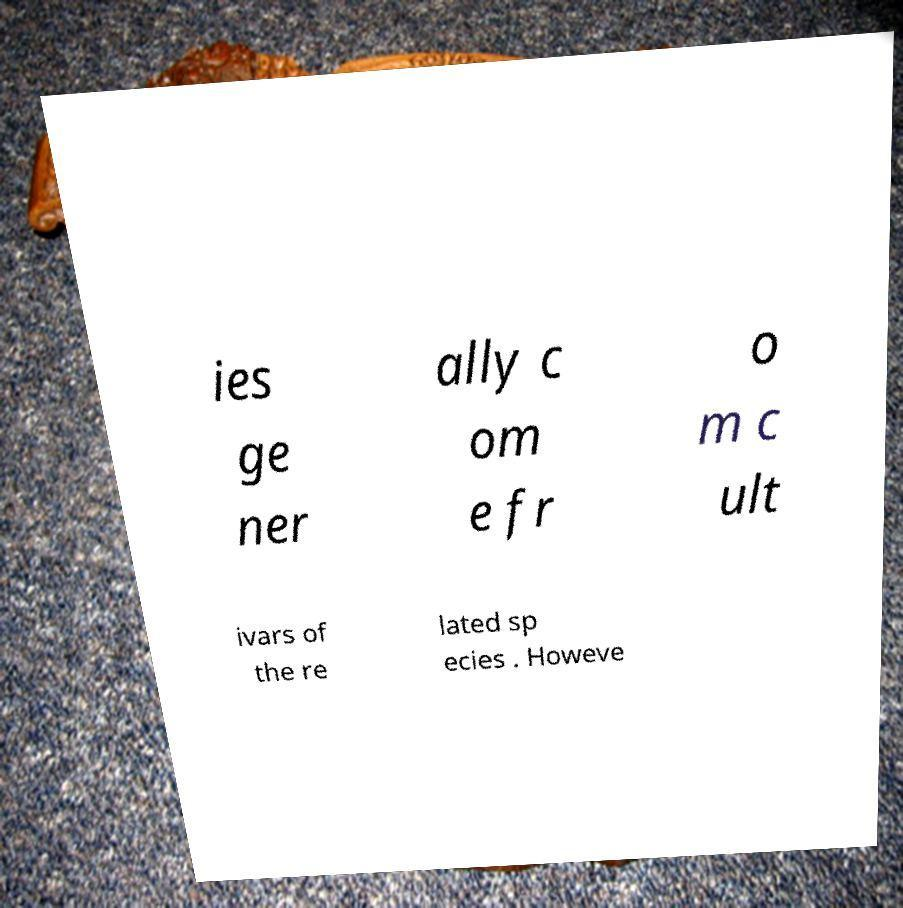There's text embedded in this image that I need extracted. Can you transcribe it verbatim? ies ge ner ally c om e fr o m c ult ivars of the re lated sp ecies . Howeve 